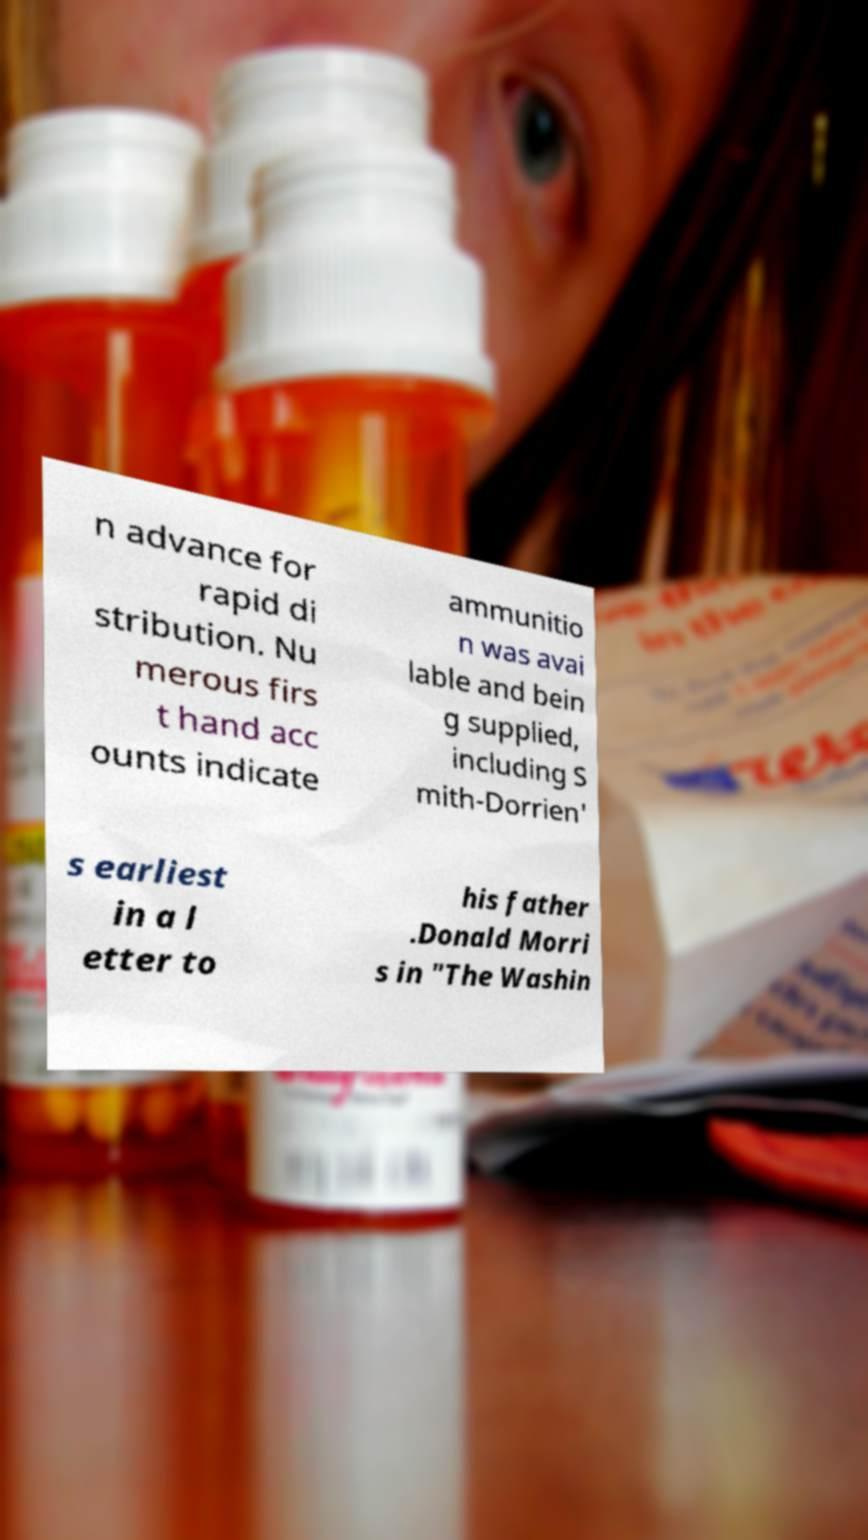For documentation purposes, I need the text within this image transcribed. Could you provide that? n advance for rapid di stribution. Nu merous firs t hand acc ounts indicate ammunitio n was avai lable and bein g supplied, including S mith-Dorrien' s earliest in a l etter to his father .Donald Morri s in "The Washin 